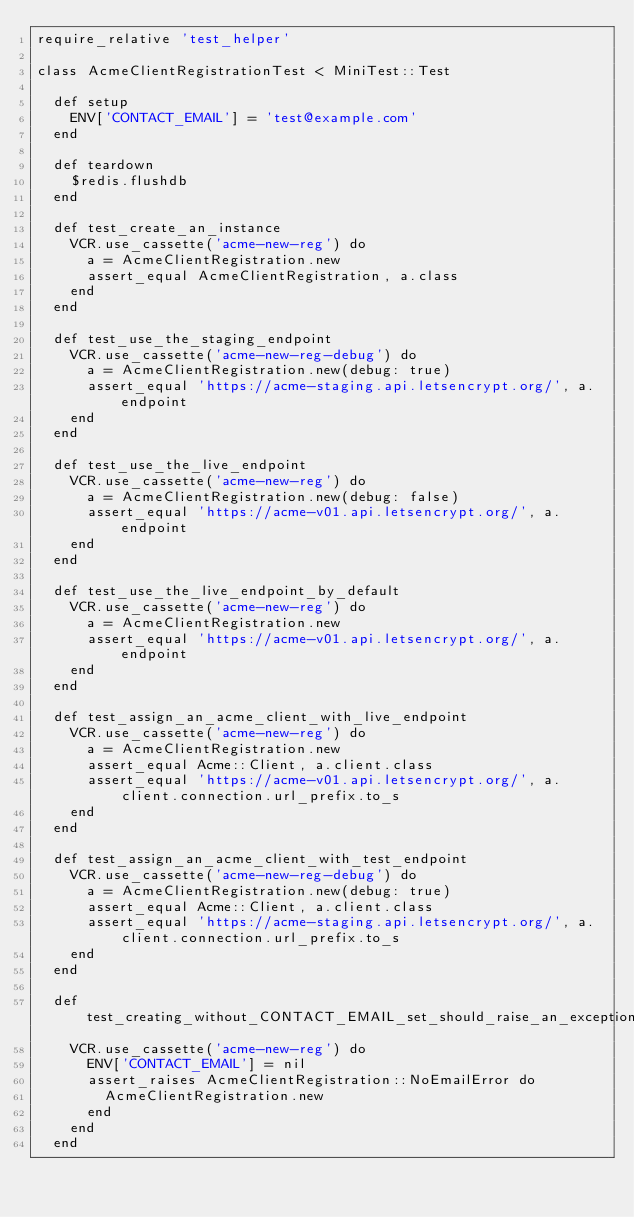<code> <loc_0><loc_0><loc_500><loc_500><_Ruby_>require_relative 'test_helper'

class AcmeClientRegistrationTest < MiniTest::Test

  def setup
    ENV['CONTACT_EMAIL'] = 'test@example.com'
  end

  def teardown
    $redis.flushdb
  end

  def test_create_an_instance
    VCR.use_cassette('acme-new-reg') do
      a = AcmeClientRegistration.new
      assert_equal AcmeClientRegistration, a.class
    end
  end

  def test_use_the_staging_endpoint
    VCR.use_cassette('acme-new-reg-debug') do
      a = AcmeClientRegistration.new(debug: true)
      assert_equal 'https://acme-staging.api.letsencrypt.org/', a.endpoint
    end
  end

  def test_use_the_live_endpoint
    VCR.use_cassette('acme-new-reg') do
      a = AcmeClientRegistration.new(debug: false)
      assert_equal 'https://acme-v01.api.letsencrypt.org/', a.endpoint
    end
  end

  def test_use_the_live_endpoint_by_default
    VCR.use_cassette('acme-new-reg') do
      a = AcmeClientRegistration.new
      assert_equal 'https://acme-v01.api.letsencrypt.org/', a.endpoint
    end
  end

  def test_assign_an_acme_client_with_live_endpoint
    VCR.use_cassette('acme-new-reg') do
      a = AcmeClientRegistration.new
      assert_equal Acme::Client, a.client.class
      assert_equal 'https://acme-v01.api.letsencrypt.org/', a.client.connection.url_prefix.to_s
    end
  end

  def test_assign_an_acme_client_with_test_endpoint
    VCR.use_cassette('acme-new-reg-debug') do
      a = AcmeClientRegistration.new(debug: true)
      assert_equal Acme::Client, a.client.class
      assert_equal 'https://acme-staging.api.letsencrypt.org/', a.client.connection.url_prefix.to_s
    end
  end

  def test_creating_without_CONTACT_EMAIL_set_should_raise_an_exception
    VCR.use_cassette('acme-new-reg') do
      ENV['CONTACT_EMAIL'] = nil
      assert_raises AcmeClientRegistration::NoEmailError do
        AcmeClientRegistration.new
      end
    end
  end
</code> 